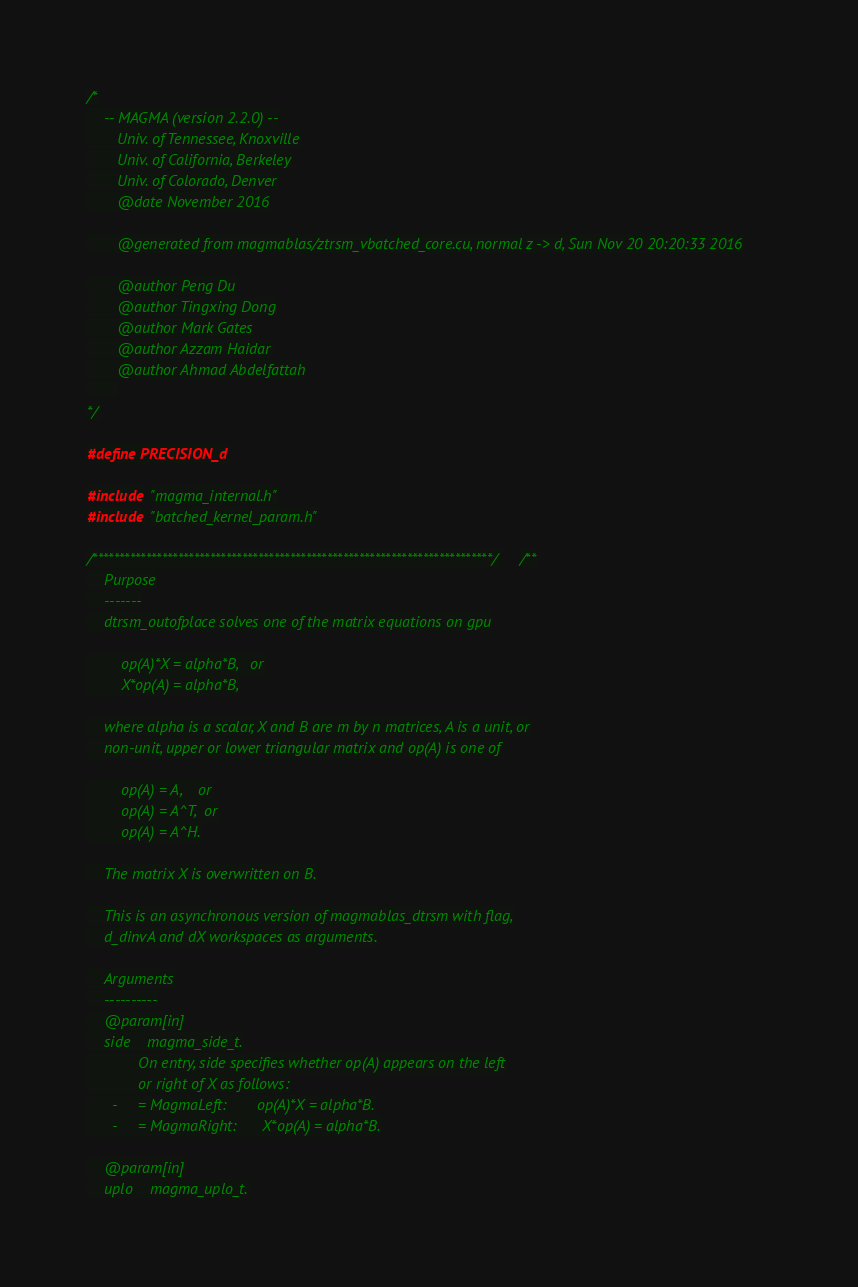Convert code to text. <code><loc_0><loc_0><loc_500><loc_500><_Cuda_>/*
    -- MAGMA (version 2.2.0) --
       Univ. of Tennessee, Knoxville
       Univ. of California, Berkeley
       Univ. of Colorado, Denver
       @date November 2016

       @generated from magmablas/ztrsm_vbatched_core.cu, normal z -> d, Sun Nov 20 20:20:33 2016

       @author Peng Du
       @author Tingxing Dong
       @author Mark Gates
       @author Azzam Haidar
       @author Ahmad Abdelfattah
       
*/

#define PRECISION_d

#include "magma_internal.h"
#include "batched_kernel_param.h"

/***************************************************************************//**
    Purpose
    -------
    dtrsm_outofplace solves one of the matrix equations on gpu

        op(A)*X = alpha*B,   or
        X*op(A) = alpha*B,

    where alpha is a scalar, X and B are m by n matrices, A is a unit, or
    non-unit, upper or lower triangular matrix and op(A) is one of

        op(A) = A,    or
        op(A) = A^T,  or
        op(A) = A^H.

    The matrix X is overwritten on B.

    This is an asynchronous version of magmablas_dtrsm with flag,
    d_dinvA and dX workspaces as arguments.

    Arguments
    ----------
    @param[in]
    side    magma_side_t.
            On entry, side specifies whether op(A) appears on the left
            or right of X as follows:
      -     = MagmaLeft:       op(A)*X = alpha*B.
      -     = MagmaRight:      X*op(A) = alpha*B.

    @param[in]
    uplo    magma_uplo_t.</code> 